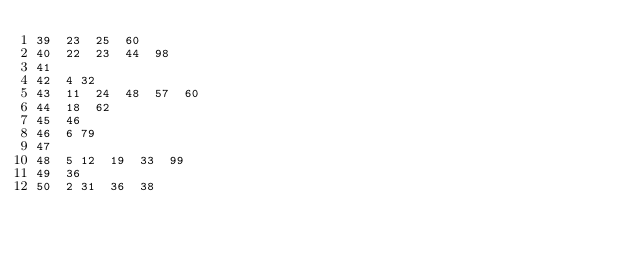Convert code to text. <code><loc_0><loc_0><loc_500><loc_500><_Perl_>39	23	25	60
40	22	23	44	98
41
42	4	32
43	11	24	48	57	60
44	18	62
45	46
46	6	79
47
48	5	12	19	33	99
49	36
50	2	31	36	38</code> 